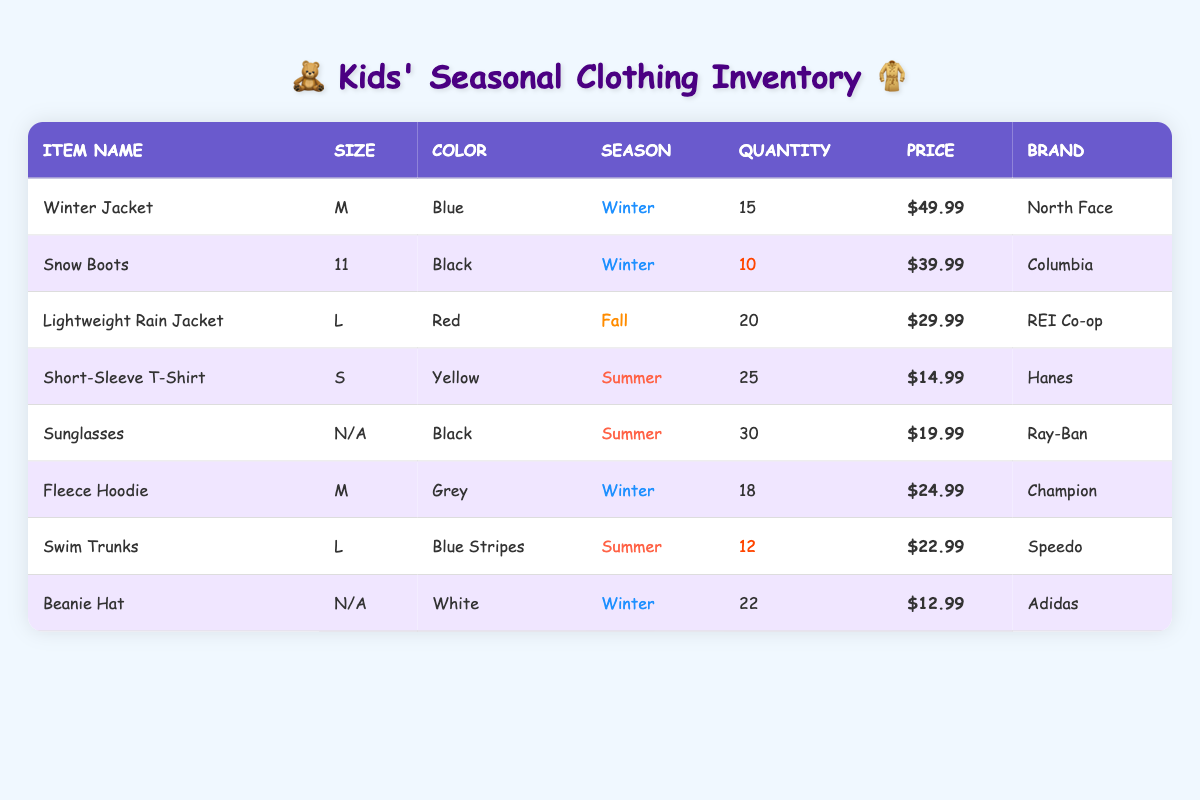What is the total quantity of Winter clothing items available? The table lists three Winter items: Winter Jacket (15), Snow Boots (10), Fleece Hoodie (18), and Beanie Hat (22). To find the total quantity, add these amounts: 15 + 10 + 18 + 22 = 75.
Answer: 75 How many items are categorized as Summer clothing? In the table, there are three Summer items: Short-Sleeve T-Shirt, Sunglasses, and Swim Trunks. Each has quantities: 25, 30, and 12, respectively.
Answer: 3 Is there a Winter item from the brand Adidas? The table shows a Winter item called Beanie Hat with the brand Adidas. Therefore, the statement is true.
Answer: Yes What is the price difference between the most expensive and the least expensive item? The most expensive Winter item is the Winter Jacket at $49.99, while the least expensive item is the Beanie Hat at $12.99. The price difference is calculated as: 49.99 - 12.99 = 37.00.
Answer: 37.00 How many items have a quantity lower than 15? From the table, the Snow Boots (10), Swim Trunks (12), and there are no other items with quantities below 15. Thus, the total count is 2.
Answer: 2 What is the average price of Summer clothing items? There are three Summer items: Short-Sleeve T-Shirt ($14.99), Sunglasses ($19.99), and Swim Trunks ($22.99). To find the average, add the prices: 14.99 + 19.99 + 22.99 = 57.97, then divide by 3: 57.97 / 3 = 19.32.
Answer: 19.32 Are there any Summer items that are out of stock? The table lists quantities for all Summer items: Short-Sleeve T-Shirt (25), Sunglasses (30), and Swim Trunks (12). However, all items have quantities greater than zero, indicating they are in stock.
Answer: No What is the total price of all Winter items combined? The prices for Winter items are: Winter Jacket ($49.99), Snow Boots ($39.99), Fleece Hoodie ($24.99), and Beanie Hat ($12.99). The total is calculated as: 49.99 + 39.99 + 24.99 + 12.99 = 127.96.
Answer: 127.96 